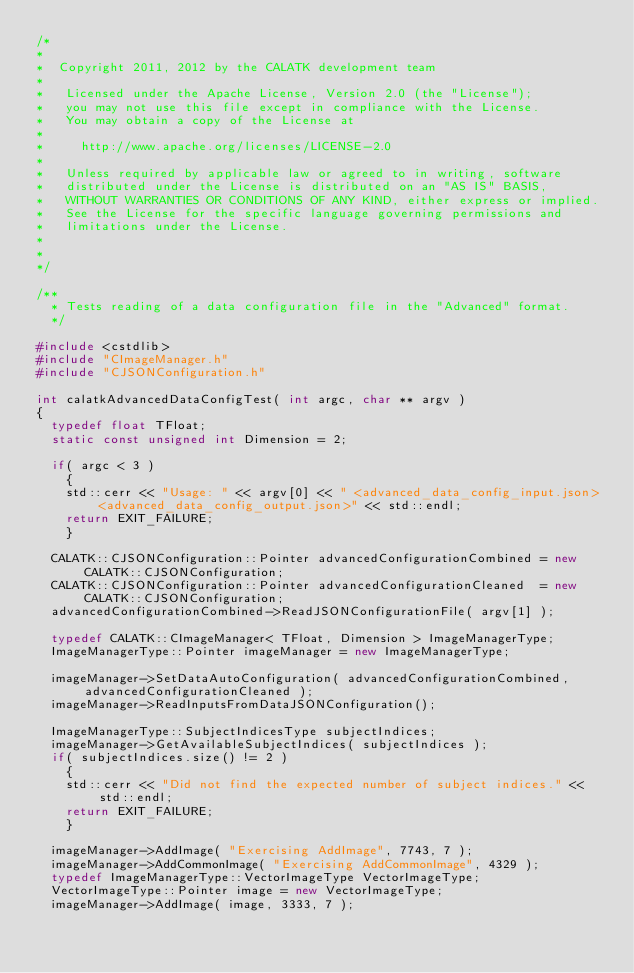Convert code to text. <code><loc_0><loc_0><loc_500><loc_500><_C++_>/*
*
*  Copyright 2011, 2012 by the CALATK development team
*
*   Licensed under the Apache License, Version 2.0 (the "License");
*   you may not use this file except in compliance with the License.
*   You may obtain a copy of the License at
*
*     http://www.apache.org/licenses/LICENSE-2.0
*
*   Unless required by applicable law or agreed to in writing, software
*   distributed under the License is distributed on an "AS IS" BASIS,
*   WITHOUT WARRANTIES OR CONDITIONS OF ANY KIND, either express or implied.
*   See the License for the specific language governing permissions and
*   limitations under the License.
*
*
*/

/**
  * Tests reading of a data configuration file in the "Advanced" format.
  */

#include <cstdlib>
#include "CImageManager.h"
#include "CJSONConfiguration.h"

int calatkAdvancedDataConfigTest( int argc, char ** argv )
{
  typedef float TFloat;
  static const unsigned int Dimension = 2;

  if( argc < 3 )
    {
    std::cerr << "Usage: " << argv[0] << " <advanced_data_config_input.json> <advanced_data_config_output.json>" << std::endl;
    return EXIT_FAILURE;
    }

  CALATK::CJSONConfiguration::Pointer advancedConfigurationCombined = new CALATK::CJSONConfiguration;
  CALATK::CJSONConfiguration::Pointer advancedConfigurationCleaned  = new CALATK::CJSONConfiguration;
  advancedConfigurationCombined->ReadJSONConfigurationFile( argv[1] );

  typedef CALATK::CImageManager< TFloat, Dimension > ImageManagerType;
  ImageManagerType::Pointer imageManager = new ImageManagerType;

  imageManager->SetDataAutoConfiguration( advancedConfigurationCombined, advancedConfigurationCleaned );
  imageManager->ReadInputsFromDataJSONConfiguration();

  ImageManagerType::SubjectIndicesType subjectIndices;
  imageManager->GetAvailableSubjectIndices( subjectIndices );
  if( subjectIndices.size() != 2 )
    {
    std::cerr << "Did not find the expected number of subject indices." << std::endl;
    return EXIT_FAILURE;
    }

  imageManager->AddImage( "Exercising AddImage", 7743, 7 );
  imageManager->AddCommonImage( "Exercising AddCommonImage", 4329 );
  typedef ImageManagerType::VectorImageType VectorImageType;
  VectorImageType::Pointer image = new VectorImageType;
  imageManager->AddImage( image, 3333, 7 );</code> 